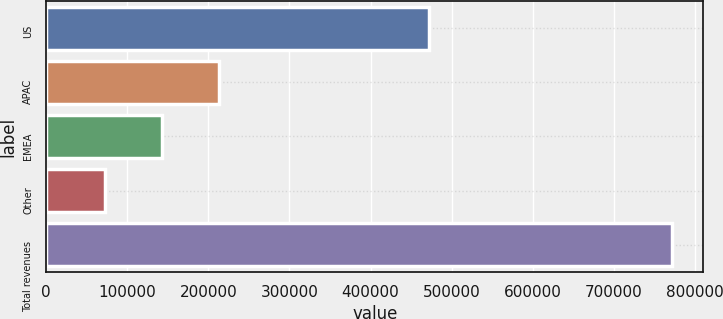Convert chart. <chart><loc_0><loc_0><loc_500><loc_500><bar_chart><fcel>US<fcel>APAC<fcel>EMEA<fcel>Other<fcel>Total revenues<nl><fcel>472700<fcel>212475<fcel>142537<fcel>72599<fcel>771978<nl></chart> 